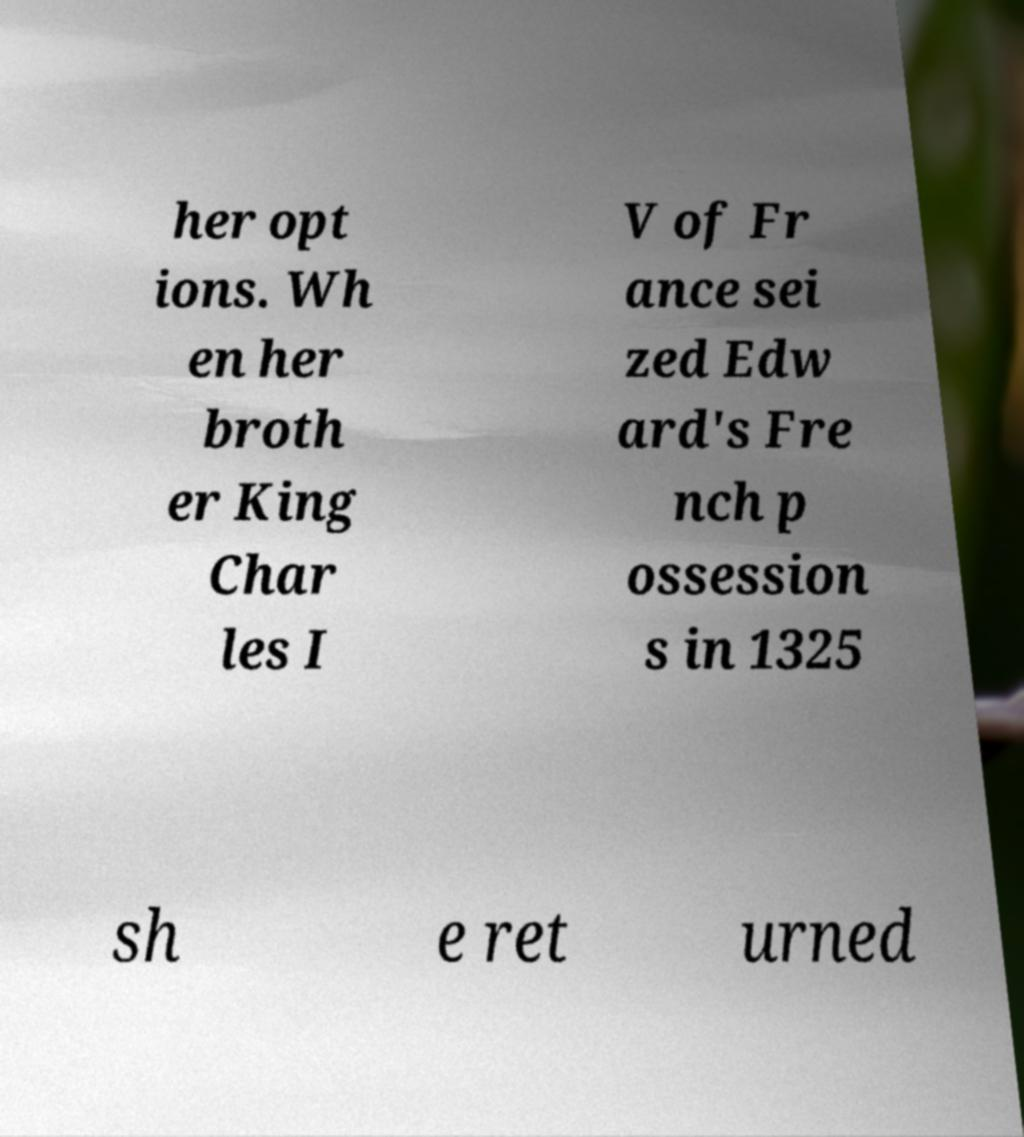I need the written content from this picture converted into text. Can you do that? her opt ions. Wh en her broth er King Char les I V of Fr ance sei zed Edw ard's Fre nch p ossession s in 1325 sh e ret urned 